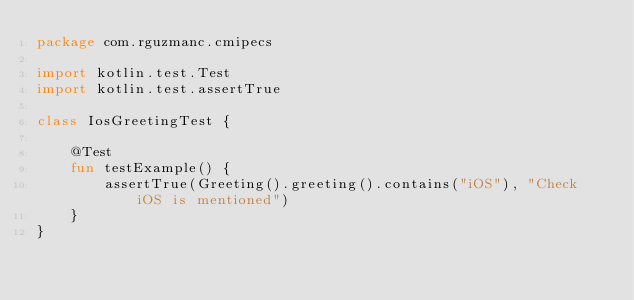Convert code to text. <code><loc_0><loc_0><loc_500><loc_500><_Kotlin_>package com.rguzmanc.cmipecs

import kotlin.test.Test
import kotlin.test.assertTrue

class IosGreetingTest {

    @Test
    fun testExample() {
        assertTrue(Greeting().greeting().contains("iOS"), "Check iOS is mentioned")
    }
}</code> 